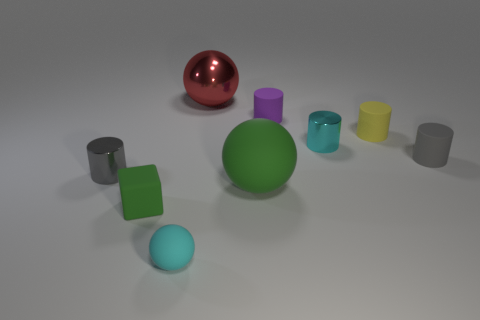Is there a large green thing of the same shape as the cyan rubber thing?
Keep it short and to the point. Yes. How many other things are there of the same shape as the tiny purple object?
Provide a short and direct response. 4. Does the purple matte thing have the same shape as the big green object that is to the right of the green cube?
Provide a short and direct response. No. There is a small cyan thing that is the same shape as the small purple matte thing; what material is it?
Keep it short and to the point. Metal. What number of small things are cyan matte spheres or cyan cylinders?
Offer a very short reply. 2. Is the number of purple objects that are in front of the tiny green cube less than the number of matte objects that are behind the cyan rubber thing?
Give a very brief answer. Yes. What number of things are large brown matte spheres or big red metal spheres?
Your answer should be compact. 1. There is a tiny rubber sphere; how many tiny blocks are left of it?
Your response must be concise. 1. Is the color of the metallic sphere the same as the big matte object?
Ensure brevity in your answer.  No. There is a small green object that is the same material as the tiny purple cylinder; what is its shape?
Keep it short and to the point. Cube. 